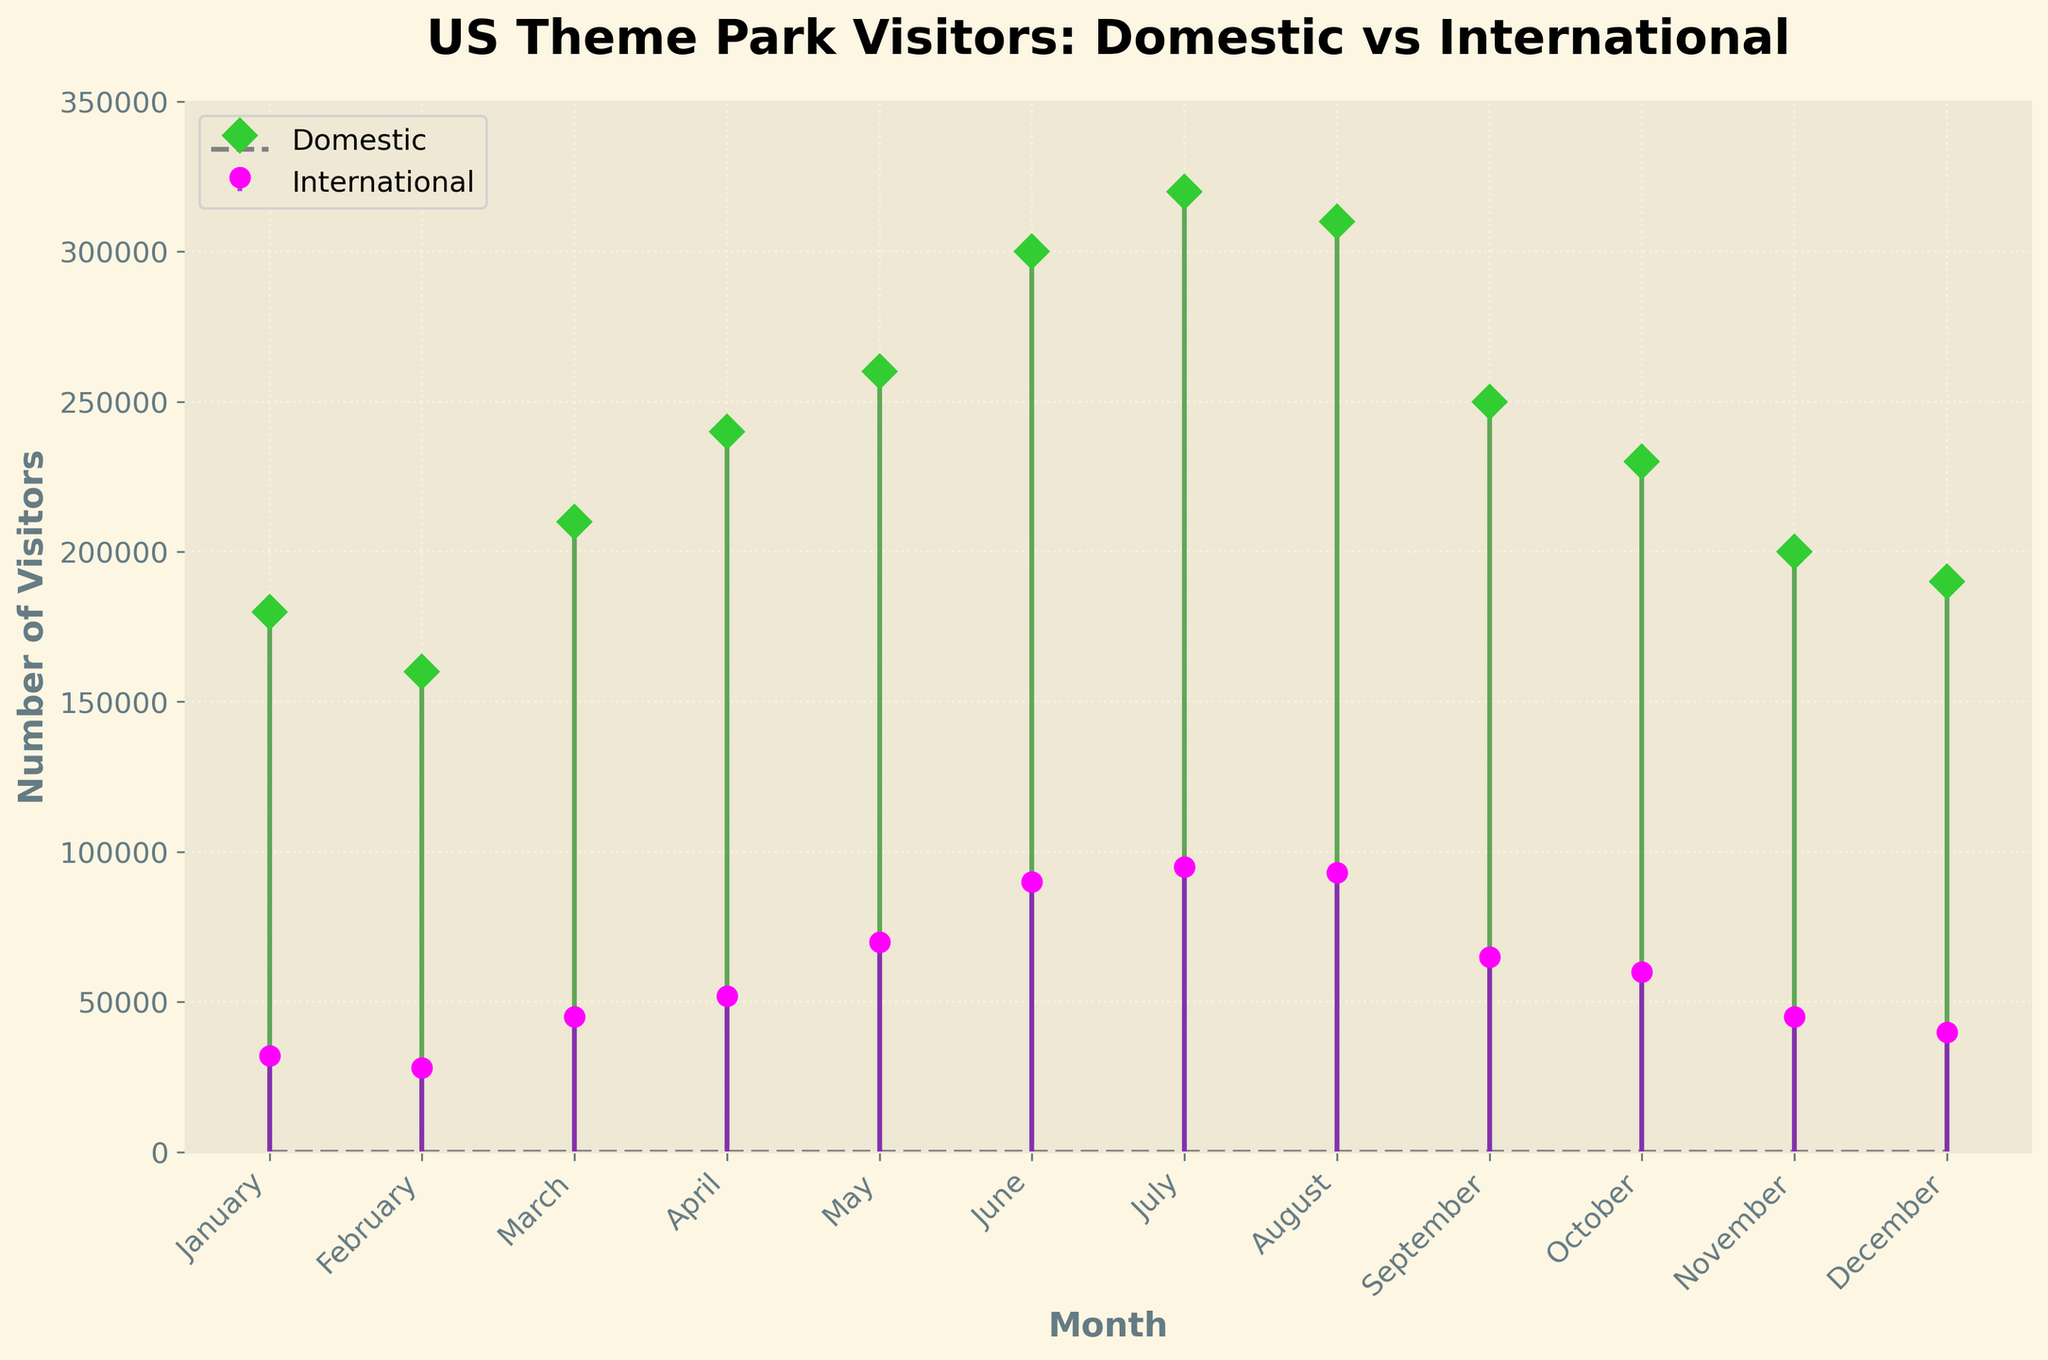What is the title of the plot? The title of the plot is displayed at the top and clearly states the subject of the figure.
Answer: US Theme Park Visitors: Domestic vs International What is the maximum value for domestic visitors, and in which month does it occur? The tallest stem for the domestic line represents the maximum value. Specifically, the peak number is highest in the month corresponding to this stem.
Answer: July, 320,000 How does the number of international visitors in January compare to July? Look at the heights of stems for the international visitors in January and July, then compare them.
Answer: The number in July is 63,000 higher than in January (95,000 vs. 32,000) Which month sees the lowest number of domestic visitors? Determine which month has the shortest stem for the domestic visitors.
Answer: February, 160,000 What is the total number of visitors (domestic and international) in June? Add the domestic and international visitor counts for June.
Answer: 390,000 (300,000 + 90,000) By how much do domestic visitors exceed international visitors in May? Subtract the number of international visitors from the number of domestic visitors in May.
Answer: 190,000 (260,000 - 70,000) Which month shows the smallest difference between domestic and international visitors? Calculate the difference between domestic and international visitors for each month to find the smallest difference.
Answer: August (Difference: 217,000 - 93,000 = 117,000) In which months do international visitors exceed 50,000? Identify months where the international visitors' stems are above the 50,000 mark.
Answer: March, April, May, June, July, August, September, October What is the overall trend for domestic visitor numbers throughout the year? Observe the trend of the domestic visitor stems from January to December to deduce whether they generally increase, decrease, or follow another pattern.
Answer: Overall increasing till July then decreasing In which month is the gap between domestic and international visitors the largest? Find and compare the absolute differences between domestic and international visitor numbers month-by-month to identify the largest gap.
Answer: July (320,000 - 95,000 = 225,000) 